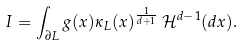<formula> <loc_0><loc_0><loc_500><loc_500>I = \int _ { \partial L } g ( x ) \kappa _ { L } ( x ) ^ { \frac { 1 } { d + 1 } } \, \mathcal { H } ^ { d - 1 } ( d x ) .</formula> 